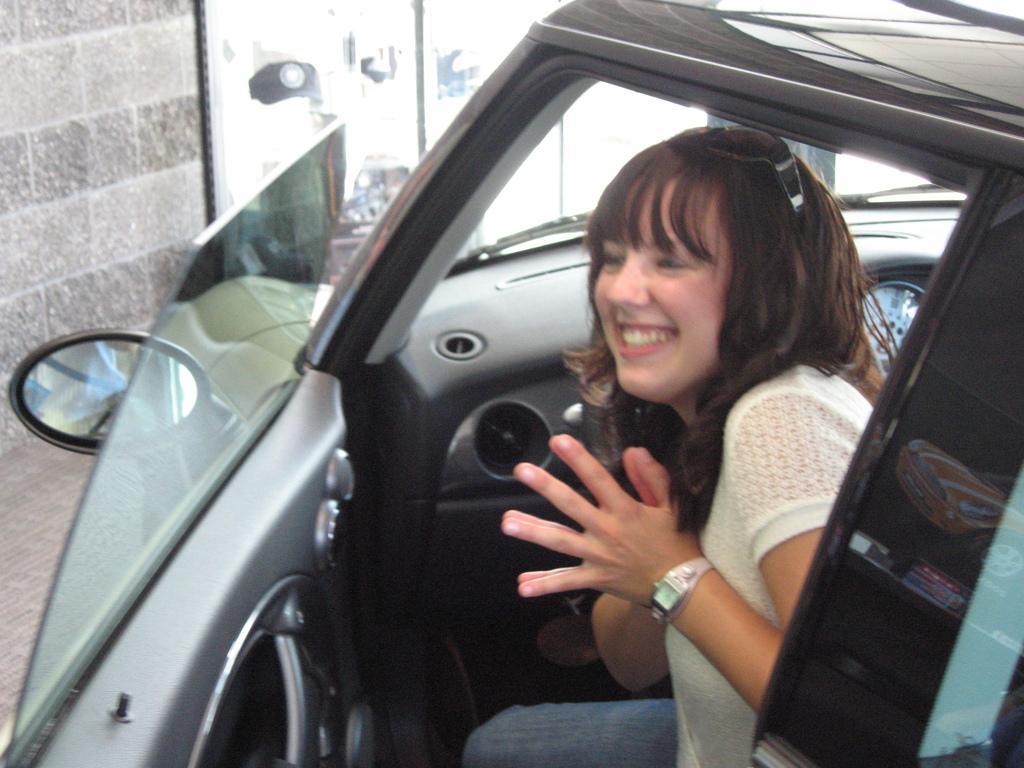Please provide a concise description of this image. In the picture we can see a woman sitting in a car and she is smiling, she is wearing a white dress with a wrist watch. The car is black, and blue in colour. In the background we can find a wall, a glass doors. 